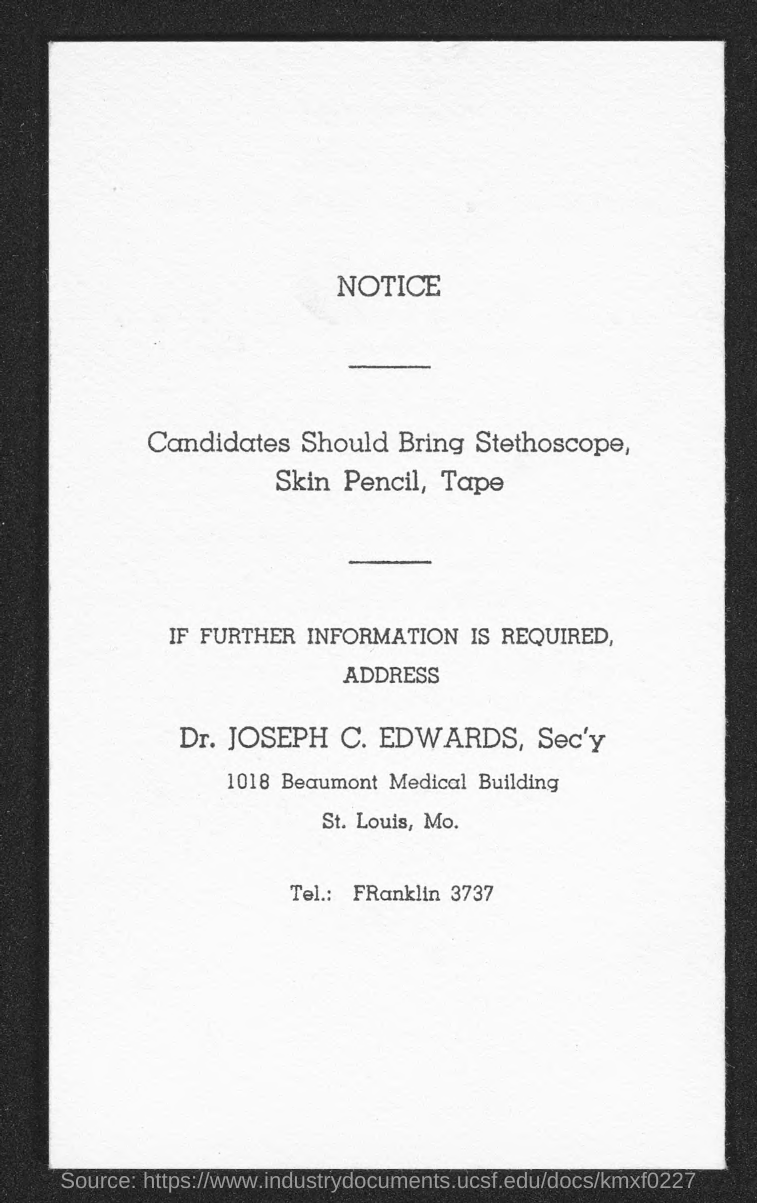Point out several critical features in this image. This is a declaration that this documentation is a notice. The telephone number given is 3737. The person to contact for further information is Dr. JOSEPH C. EDWARDS. It is recommended that candidates bring a stethoscope, skin pencil, and tape to the event for practical demonstrations. 